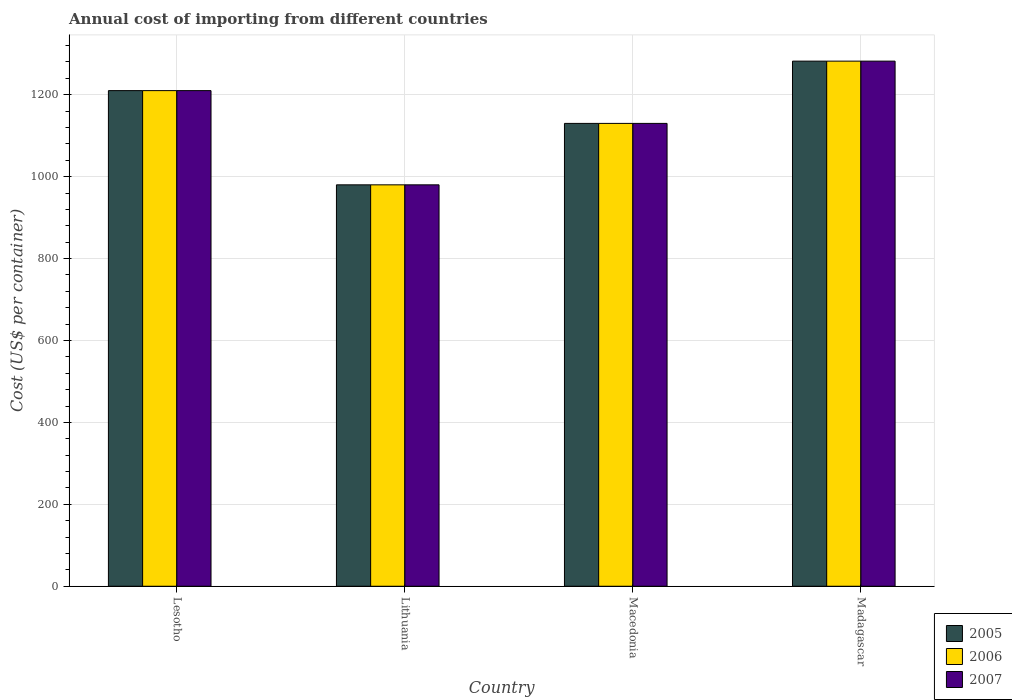How many different coloured bars are there?
Your answer should be compact. 3. How many groups of bars are there?
Make the answer very short. 4. Are the number of bars on each tick of the X-axis equal?
Provide a succinct answer. Yes. How many bars are there on the 1st tick from the left?
Provide a succinct answer. 3. What is the label of the 3rd group of bars from the left?
Provide a succinct answer. Macedonia. What is the total annual cost of importing in 2005 in Lithuania?
Make the answer very short. 980. Across all countries, what is the maximum total annual cost of importing in 2005?
Provide a short and direct response. 1282. Across all countries, what is the minimum total annual cost of importing in 2007?
Keep it short and to the point. 980. In which country was the total annual cost of importing in 2005 maximum?
Provide a short and direct response. Madagascar. In which country was the total annual cost of importing in 2006 minimum?
Ensure brevity in your answer.  Lithuania. What is the total total annual cost of importing in 2006 in the graph?
Offer a terse response. 4602. What is the difference between the total annual cost of importing in 2005 in Lithuania and that in Madagascar?
Ensure brevity in your answer.  -302. What is the difference between the total annual cost of importing in 2006 in Macedonia and the total annual cost of importing in 2007 in Lithuania?
Your answer should be compact. 150. What is the average total annual cost of importing in 2006 per country?
Your answer should be very brief. 1150.5. What is the difference between the total annual cost of importing of/in 2007 and total annual cost of importing of/in 2006 in Macedonia?
Offer a very short reply. 0. What is the ratio of the total annual cost of importing in 2006 in Macedonia to that in Madagascar?
Offer a very short reply. 0.88. What is the difference between the highest and the second highest total annual cost of importing in 2007?
Your response must be concise. -72. What is the difference between the highest and the lowest total annual cost of importing in 2005?
Give a very brief answer. 302. Is the sum of the total annual cost of importing in 2007 in Lesotho and Macedonia greater than the maximum total annual cost of importing in 2006 across all countries?
Give a very brief answer. Yes. What does the 1st bar from the right in Macedonia represents?
Keep it short and to the point. 2007. How many countries are there in the graph?
Your answer should be very brief. 4. Are the values on the major ticks of Y-axis written in scientific E-notation?
Offer a terse response. No. Does the graph contain grids?
Your response must be concise. Yes. How are the legend labels stacked?
Ensure brevity in your answer.  Vertical. What is the title of the graph?
Provide a short and direct response. Annual cost of importing from different countries. Does "1963" appear as one of the legend labels in the graph?
Make the answer very short. No. What is the label or title of the Y-axis?
Offer a very short reply. Cost (US$ per container). What is the Cost (US$ per container) in 2005 in Lesotho?
Offer a very short reply. 1210. What is the Cost (US$ per container) of 2006 in Lesotho?
Make the answer very short. 1210. What is the Cost (US$ per container) of 2007 in Lesotho?
Provide a succinct answer. 1210. What is the Cost (US$ per container) of 2005 in Lithuania?
Make the answer very short. 980. What is the Cost (US$ per container) in 2006 in Lithuania?
Provide a succinct answer. 980. What is the Cost (US$ per container) in 2007 in Lithuania?
Ensure brevity in your answer.  980. What is the Cost (US$ per container) of 2005 in Macedonia?
Offer a terse response. 1130. What is the Cost (US$ per container) of 2006 in Macedonia?
Keep it short and to the point. 1130. What is the Cost (US$ per container) of 2007 in Macedonia?
Your response must be concise. 1130. What is the Cost (US$ per container) of 2005 in Madagascar?
Your answer should be compact. 1282. What is the Cost (US$ per container) of 2006 in Madagascar?
Your response must be concise. 1282. What is the Cost (US$ per container) in 2007 in Madagascar?
Offer a very short reply. 1282. Across all countries, what is the maximum Cost (US$ per container) in 2005?
Your answer should be very brief. 1282. Across all countries, what is the maximum Cost (US$ per container) of 2006?
Offer a terse response. 1282. Across all countries, what is the maximum Cost (US$ per container) of 2007?
Your response must be concise. 1282. Across all countries, what is the minimum Cost (US$ per container) in 2005?
Your response must be concise. 980. Across all countries, what is the minimum Cost (US$ per container) in 2006?
Offer a terse response. 980. Across all countries, what is the minimum Cost (US$ per container) of 2007?
Offer a very short reply. 980. What is the total Cost (US$ per container) of 2005 in the graph?
Offer a very short reply. 4602. What is the total Cost (US$ per container) in 2006 in the graph?
Give a very brief answer. 4602. What is the total Cost (US$ per container) in 2007 in the graph?
Offer a terse response. 4602. What is the difference between the Cost (US$ per container) of 2005 in Lesotho and that in Lithuania?
Provide a succinct answer. 230. What is the difference between the Cost (US$ per container) of 2006 in Lesotho and that in Lithuania?
Give a very brief answer. 230. What is the difference between the Cost (US$ per container) of 2007 in Lesotho and that in Lithuania?
Offer a terse response. 230. What is the difference between the Cost (US$ per container) in 2005 in Lesotho and that in Macedonia?
Your answer should be compact. 80. What is the difference between the Cost (US$ per container) in 2007 in Lesotho and that in Macedonia?
Offer a very short reply. 80. What is the difference between the Cost (US$ per container) of 2005 in Lesotho and that in Madagascar?
Provide a short and direct response. -72. What is the difference between the Cost (US$ per container) of 2006 in Lesotho and that in Madagascar?
Keep it short and to the point. -72. What is the difference between the Cost (US$ per container) of 2007 in Lesotho and that in Madagascar?
Offer a terse response. -72. What is the difference between the Cost (US$ per container) in 2005 in Lithuania and that in Macedonia?
Make the answer very short. -150. What is the difference between the Cost (US$ per container) of 2006 in Lithuania and that in Macedonia?
Your answer should be compact. -150. What is the difference between the Cost (US$ per container) of 2007 in Lithuania and that in Macedonia?
Make the answer very short. -150. What is the difference between the Cost (US$ per container) in 2005 in Lithuania and that in Madagascar?
Ensure brevity in your answer.  -302. What is the difference between the Cost (US$ per container) of 2006 in Lithuania and that in Madagascar?
Your answer should be compact. -302. What is the difference between the Cost (US$ per container) in 2007 in Lithuania and that in Madagascar?
Provide a short and direct response. -302. What is the difference between the Cost (US$ per container) of 2005 in Macedonia and that in Madagascar?
Ensure brevity in your answer.  -152. What is the difference between the Cost (US$ per container) in 2006 in Macedonia and that in Madagascar?
Ensure brevity in your answer.  -152. What is the difference between the Cost (US$ per container) in 2007 in Macedonia and that in Madagascar?
Ensure brevity in your answer.  -152. What is the difference between the Cost (US$ per container) in 2005 in Lesotho and the Cost (US$ per container) in 2006 in Lithuania?
Provide a short and direct response. 230. What is the difference between the Cost (US$ per container) of 2005 in Lesotho and the Cost (US$ per container) of 2007 in Lithuania?
Give a very brief answer. 230. What is the difference between the Cost (US$ per container) in 2006 in Lesotho and the Cost (US$ per container) in 2007 in Lithuania?
Your answer should be very brief. 230. What is the difference between the Cost (US$ per container) in 2005 in Lesotho and the Cost (US$ per container) in 2006 in Macedonia?
Ensure brevity in your answer.  80. What is the difference between the Cost (US$ per container) of 2006 in Lesotho and the Cost (US$ per container) of 2007 in Macedonia?
Keep it short and to the point. 80. What is the difference between the Cost (US$ per container) of 2005 in Lesotho and the Cost (US$ per container) of 2006 in Madagascar?
Offer a very short reply. -72. What is the difference between the Cost (US$ per container) of 2005 in Lesotho and the Cost (US$ per container) of 2007 in Madagascar?
Your response must be concise. -72. What is the difference between the Cost (US$ per container) in 2006 in Lesotho and the Cost (US$ per container) in 2007 in Madagascar?
Your answer should be compact. -72. What is the difference between the Cost (US$ per container) in 2005 in Lithuania and the Cost (US$ per container) in 2006 in Macedonia?
Offer a very short reply. -150. What is the difference between the Cost (US$ per container) of 2005 in Lithuania and the Cost (US$ per container) of 2007 in Macedonia?
Keep it short and to the point. -150. What is the difference between the Cost (US$ per container) in 2006 in Lithuania and the Cost (US$ per container) in 2007 in Macedonia?
Ensure brevity in your answer.  -150. What is the difference between the Cost (US$ per container) in 2005 in Lithuania and the Cost (US$ per container) in 2006 in Madagascar?
Ensure brevity in your answer.  -302. What is the difference between the Cost (US$ per container) of 2005 in Lithuania and the Cost (US$ per container) of 2007 in Madagascar?
Your answer should be compact. -302. What is the difference between the Cost (US$ per container) in 2006 in Lithuania and the Cost (US$ per container) in 2007 in Madagascar?
Keep it short and to the point. -302. What is the difference between the Cost (US$ per container) in 2005 in Macedonia and the Cost (US$ per container) in 2006 in Madagascar?
Make the answer very short. -152. What is the difference between the Cost (US$ per container) of 2005 in Macedonia and the Cost (US$ per container) of 2007 in Madagascar?
Provide a succinct answer. -152. What is the difference between the Cost (US$ per container) of 2006 in Macedonia and the Cost (US$ per container) of 2007 in Madagascar?
Your answer should be compact. -152. What is the average Cost (US$ per container) of 2005 per country?
Offer a terse response. 1150.5. What is the average Cost (US$ per container) of 2006 per country?
Provide a succinct answer. 1150.5. What is the average Cost (US$ per container) of 2007 per country?
Make the answer very short. 1150.5. What is the difference between the Cost (US$ per container) of 2005 and Cost (US$ per container) of 2007 in Lesotho?
Offer a terse response. 0. What is the difference between the Cost (US$ per container) of 2006 and Cost (US$ per container) of 2007 in Lesotho?
Ensure brevity in your answer.  0. What is the difference between the Cost (US$ per container) in 2005 and Cost (US$ per container) in 2006 in Lithuania?
Keep it short and to the point. 0. What is the difference between the Cost (US$ per container) of 2005 and Cost (US$ per container) of 2007 in Macedonia?
Offer a very short reply. 0. What is the difference between the Cost (US$ per container) in 2005 and Cost (US$ per container) in 2006 in Madagascar?
Your answer should be compact. 0. What is the difference between the Cost (US$ per container) in 2006 and Cost (US$ per container) in 2007 in Madagascar?
Your answer should be compact. 0. What is the ratio of the Cost (US$ per container) in 2005 in Lesotho to that in Lithuania?
Your answer should be very brief. 1.23. What is the ratio of the Cost (US$ per container) of 2006 in Lesotho to that in Lithuania?
Keep it short and to the point. 1.23. What is the ratio of the Cost (US$ per container) of 2007 in Lesotho to that in Lithuania?
Ensure brevity in your answer.  1.23. What is the ratio of the Cost (US$ per container) in 2005 in Lesotho to that in Macedonia?
Your answer should be very brief. 1.07. What is the ratio of the Cost (US$ per container) of 2006 in Lesotho to that in Macedonia?
Your answer should be very brief. 1.07. What is the ratio of the Cost (US$ per container) of 2007 in Lesotho to that in Macedonia?
Give a very brief answer. 1.07. What is the ratio of the Cost (US$ per container) of 2005 in Lesotho to that in Madagascar?
Keep it short and to the point. 0.94. What is the ratio of the Cost (US$ per container) in 2006 in Lesotho to that in Madagascar?
Keep it short and to the point. 0.94. What is the ratio of the Cost (US$ per container) of 2007 in Lesotho to that in Madagascar?
Give a very brief answer. 0.94. What is the ratio of the Cost (US$ per container) in 2005 in Lithuania to that in Macedonia?
Your answer should be very brief. 0.87. What is the ratio of the Cost (US$ per container) in 2006 in Lithuania to that in Macedonia?
Your response must be concise. 0.87. What is the ratio of the Cost (US$ per container) of 2007 in Lithuania to that in Macedonia?
Your answer should be compact. 0.87. What is the ratio of the Cost (US$ per container) of 2005 in Lithuania to that in Madagascar?
Your answer should be compact. 0.76. What is the ratio of the Cost (US$ per container) of 2006 in Lithuania to that in Madagascar?
Your response must be concise. 0.76. What is the ratio of the Cost (US$ per container) of 2007 in Lithuania to that in Madagascar?
Offer a very short reply. 0.76. What is the ratio of the Cost (US$ per container) of 2005 in Macedonia to that in Madagascar?
Keep it short and to the point. 0.88. What is the ratio of the Cost (US$ per container) of 2006 in Macedonia to that in Madagascar?
Offer a terse response. 0.88. What is the ratio of the Cost (US$ per container) of 2007 in Macedonia to that in Madagascar?
Provide a short and direct response. 0.88. What is the difference between the highest and the second highest Cost (US$ per container) in 2006?
Make the answer very short. 72. What is the difference between the highest and the lowest Cost (US$ per container) of 2005?
Make the answer very short. 302. What is the difference between the highest and the lowest Cost (US$ per container) in 2006?
Provide a succinct answer. 302. What is the difference between the highest and the lowest Cost (US$ per container) of 2007?
Ensure brevity in your answer.  302. 